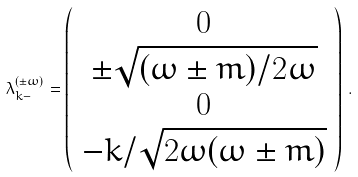Convert formula to latex. <formula><loc_0><loc_0><loc_500><loc_500>\lambda ^ { ( \pm \omega ) } _ { k - } = \left ( \begin{array} { c } 0 \\ \pm \sqrt { ( \omega \pm m ) / 2 \omega } \\ 0 \\ - k / \sqrt { 2 \omega ( \omega \pm m ) } \end{array} \right ) \, .</formula> 